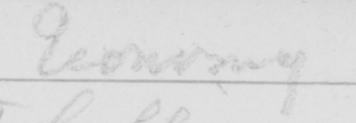What does this handwritten line say? Economy 